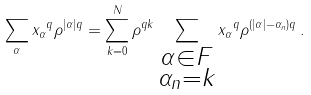Convert formula to latex. <formula><loc_0><loc_0><loc_500><loc_500>\sum _ { \alpha } \| x _ { \alpha } \| ^ { q } \rho ^ { | \alpha | q } = \sum _ { k = 0 } ^ { N } \rho ^ { q k } \sum _ { \substack { \alpha \in F \\ \alpha _ { n } = k } } \| x _ { \alpha } \| ^ { q } \rho ^ { ( | \alpha | - \alpha _ { n } ) q } \, .</formula> 